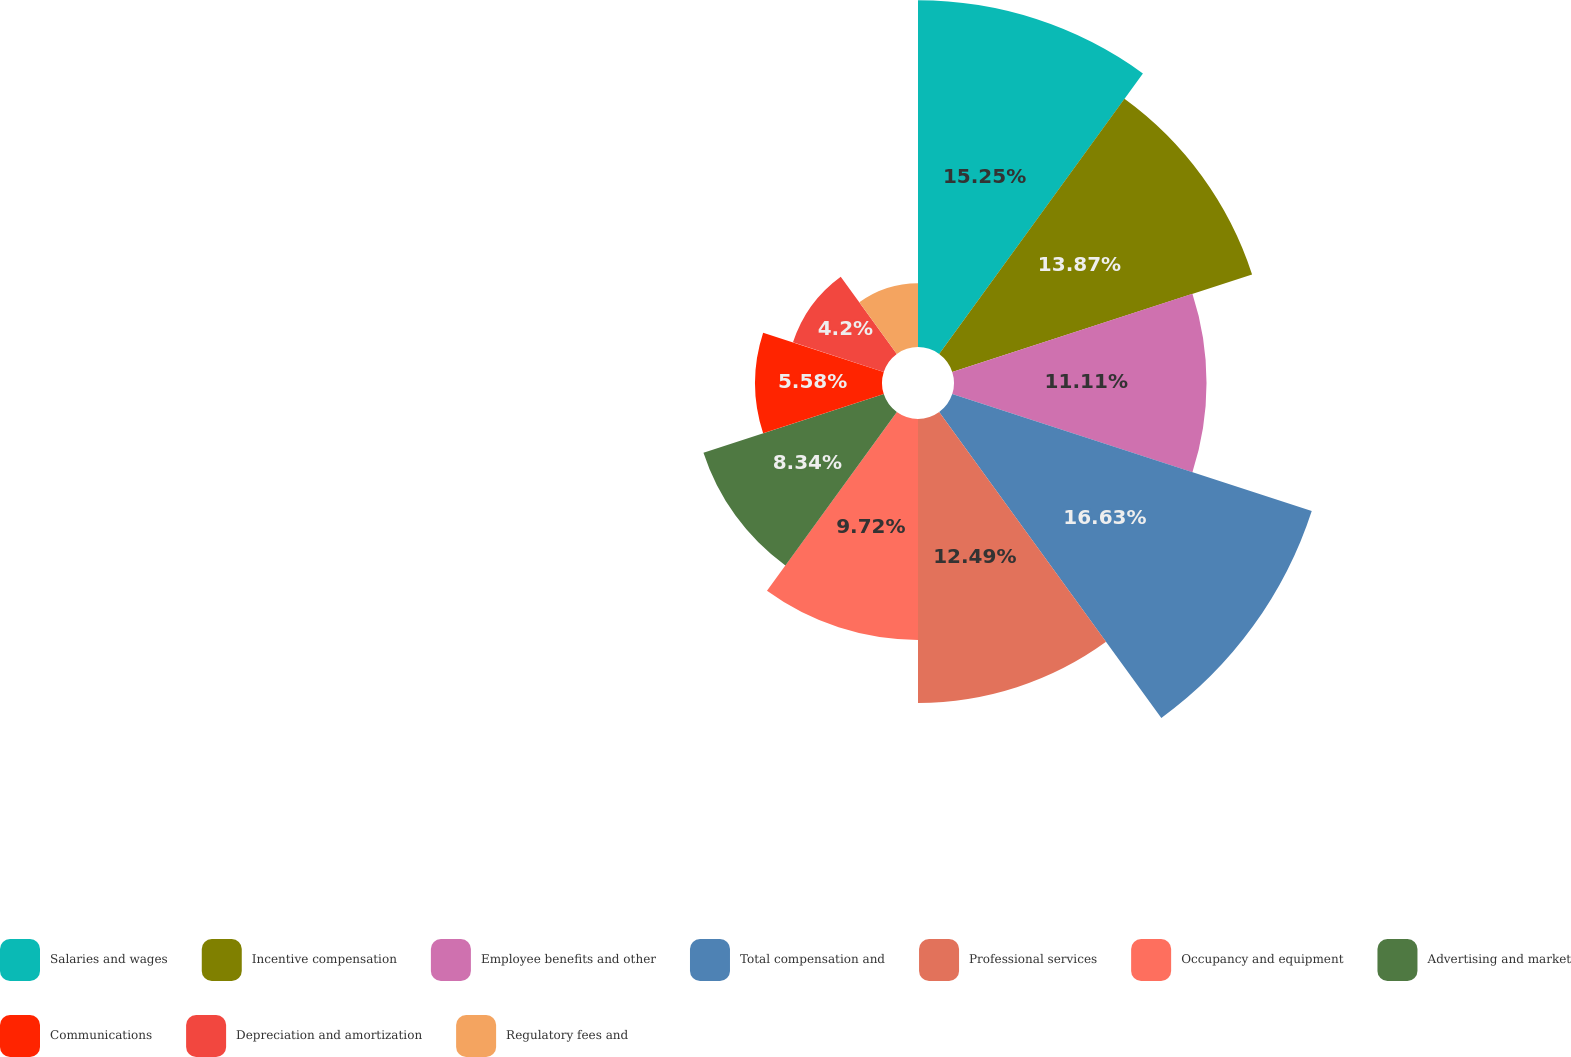<chart> <loc_0><loc_0><loc_500><loc_500><pie_chart><fcel>Salaries and wages<fcel>Incentive compensation<fcel>Employee benefits and other<fcel>Total compensation and<fcel>Professional services<fcel>Occupancy and equipment<fcel>Advertising and market<fcel>Communications<fcel>Depreciation and amortization<fcel>Regulatory fees and<nl><fcel>15.25%<fcel>13.87%<fcel>11.11%<fcel>16.63%<fcel>12.49%<fcel>9.72%<fcel>8.34%<fcel>5.58%<fcel>4.2%<fcel>2.81%<nl></chart> 